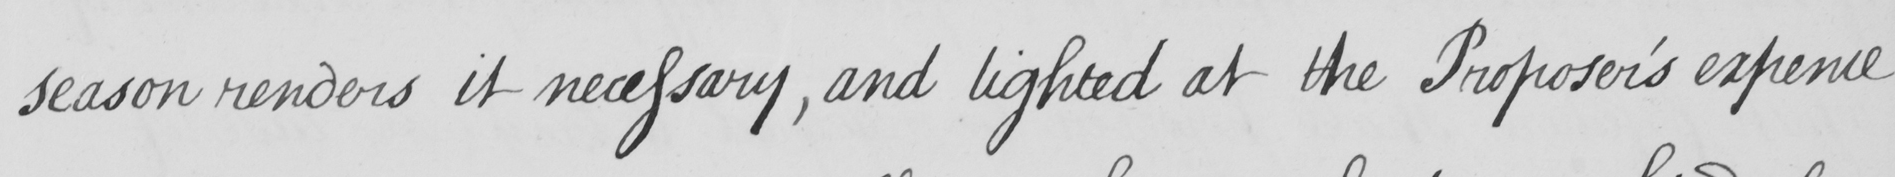Transcribe the text shown in this historical manuscript line. season renders it necessary , and lighted at the Proposer ' s expence 